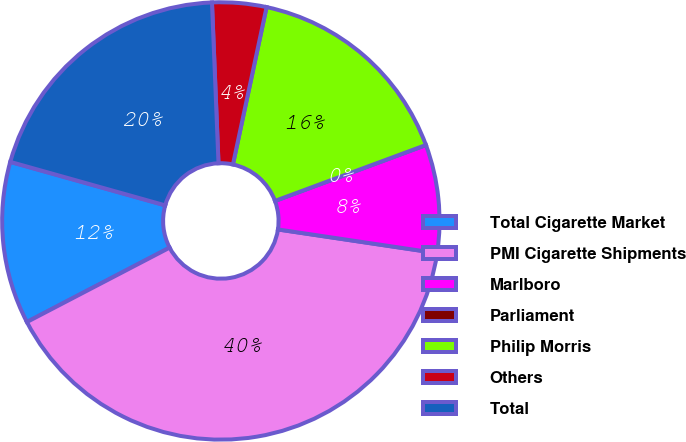Convert chart to OTSL. <chart><loc_0><loc_0><loc_500><loc_500><pie_chart><fcel>Total Cigarette Market<fcel>PMI Cigarette Shipments<fcel>Marlboro<fcel>Parliament<fcel>Philip Morris<fcel>Others<fcel>Total<nl><fcel>12.0%<fcel>40.0%<fcel>8.0%<fcel>0.0%<fcel>16.0%<fcel>4.0%<fcel>20.0%<nl></chart> 